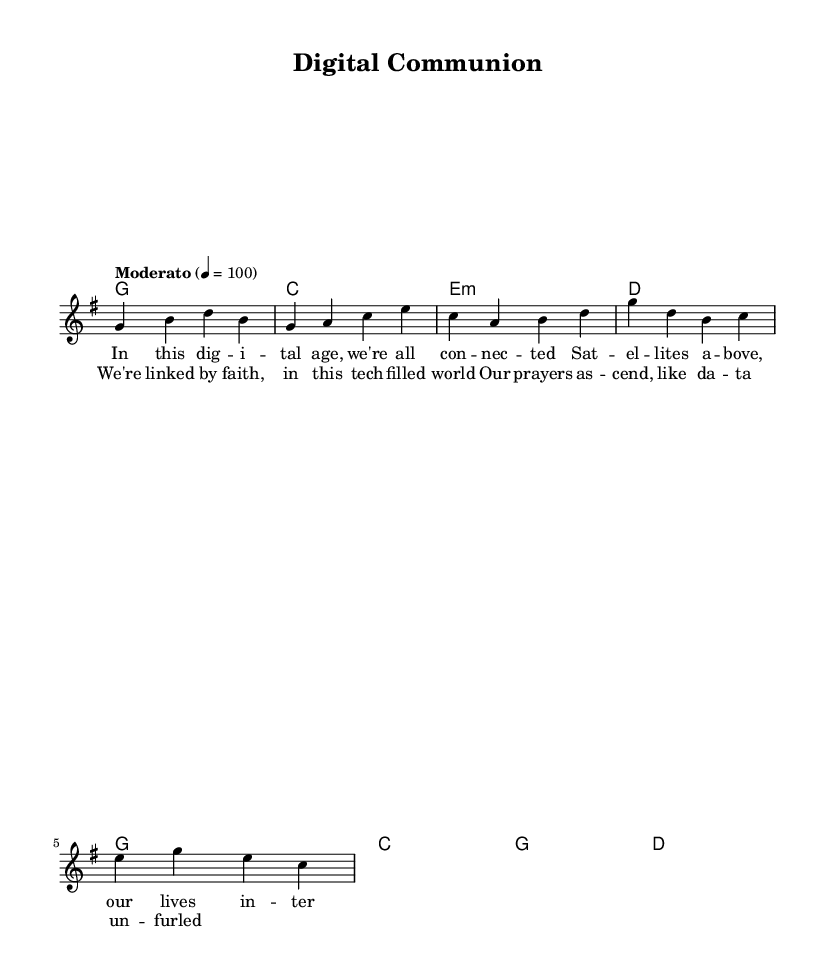What is the key signature of this music? The key signature is G major, which has one sharp (F#). This can be identified from the 'g' indicated in the global setting of the music.
Answer: G major What is the time signature of this sheet music? The time signature is 4/4, as indicated at the beginning of the global settings with '4/4'. This means there are four beats in every measure.
Answer: 4/4 What is the tempo marking for this piece? The tempo marking is "Moderato," which indicates a moderate speed for the piece. It's set at a quarter note equals 100 beats per minute, as noted in the global section.
Answer: Moderato How many measures are in the verse? The verse consists of four measures, as evidenced by the four lines of lyrics and each line containing one complete measure of music (noted with the melody).
Answer: 4 What themes are addressed in the lyrics? The lyrics address themes of technology and interconnectedness, as reflected in phrases like "digital age" and "satellites above." This connection between faith and technology aligns with the song’s overarching message.
Answer: Technology and interconnectedness What chord follows the G major chord in the harmony? The chord that follows the G major chord is C major, as noted in the chord sequence provided in the harmonies section. The sequence indicates the order of chords throughout the piece.
Answer: C major How do the chorus lyrics connect to the overall theme? The chorus lyrics emphasize unity and prayer in a technological context, illustrated by phrases like "linked by faith" and "prayers ascend like data unfurled," reinforcing the song's focus on spirituality in a modern world.
Answer: Unity and prayer 